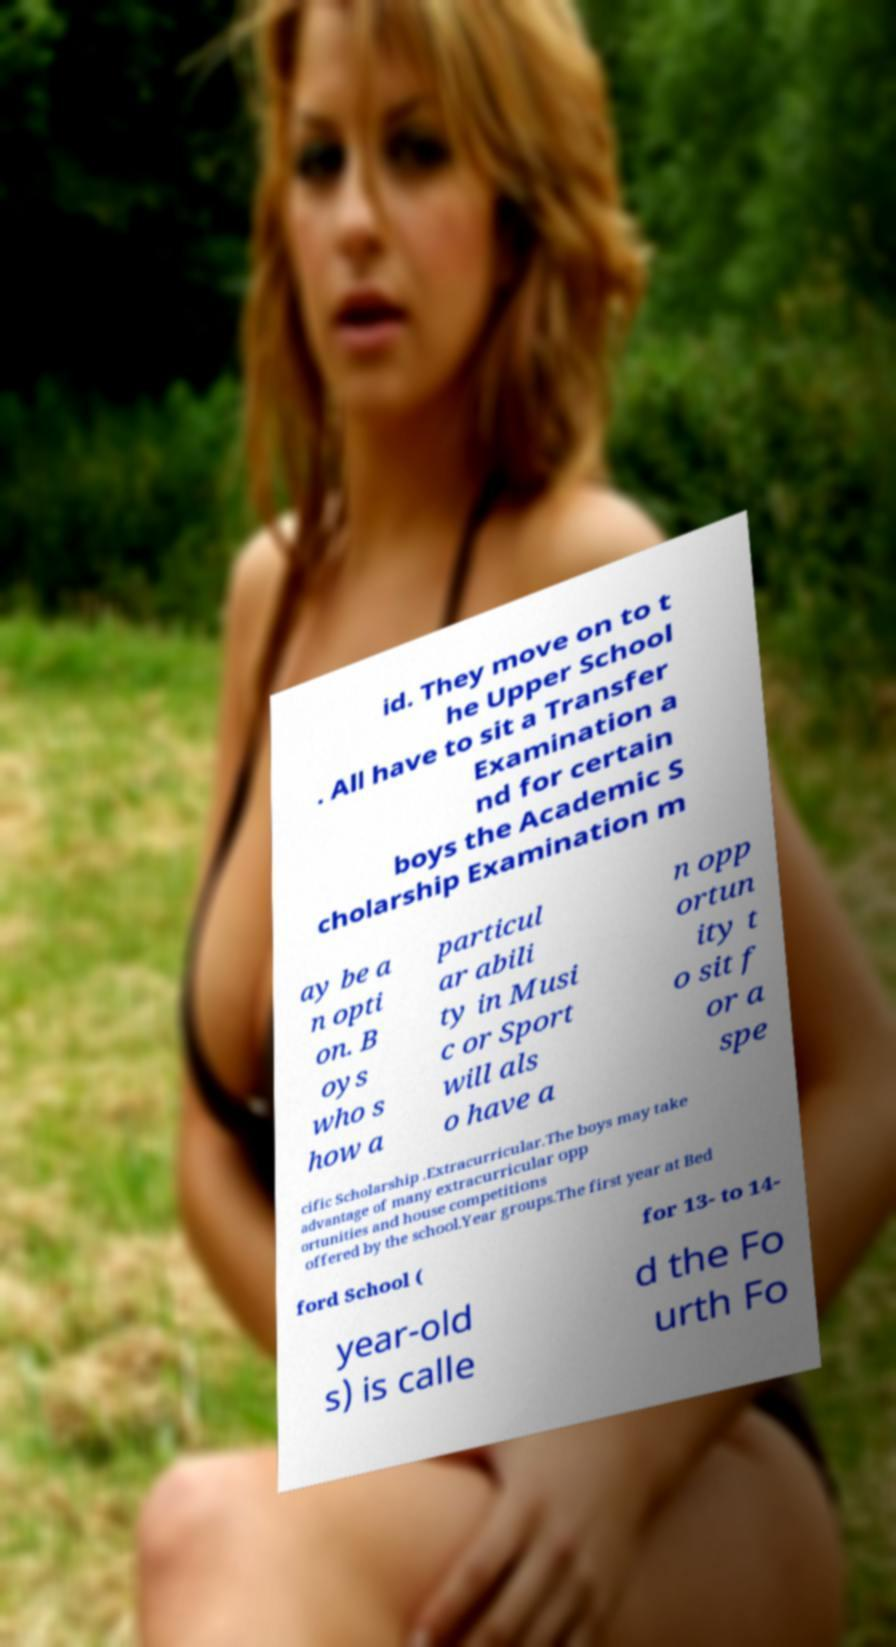I need the written content from this picture converted into text. Can you do that? id. They move on to t he Upper School . All have to sit a Transfer Examination a nd for certain boys the Academic S cholarship Examination m ay be a n opti on. B oys who s how a particul ar abili ty in Musi c or Sport will als o have a n opp ortun ity t o sit f or a spe cific Scholarship .Extracurricular.The boys may take advantage of many extracurricular opp ortunities and house competitions offered by the school.Year groups.The first year at Bed ford School ( for 13- to 14- year-old s) is calle d the Fo urth Fo 